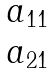<formula> <loc_0><loc_0><loc_500><loc_500>\begin{matrix} a _ { 1 1 } \\ a _ { 2 1 } \end{matrix}</formula> 